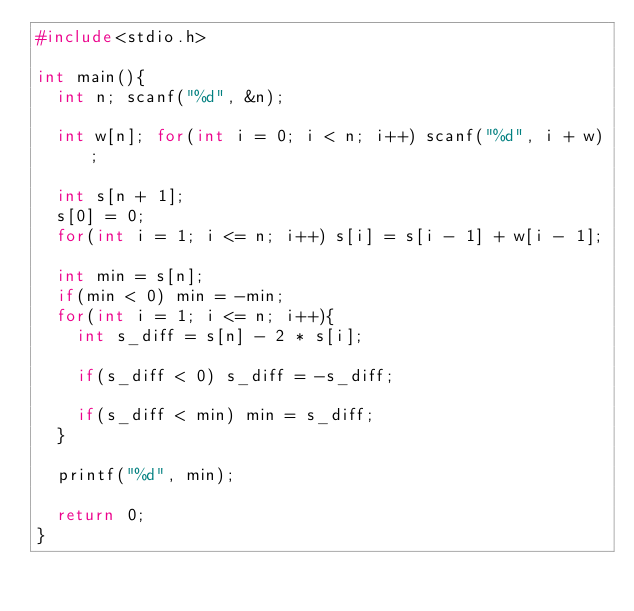<code> <loc_0><loc_0><loc_500><loc_500><_C_>#include<stdio.h>

int main(){
  int n; scanf("%d", &n);
  
  int w[n]; for(int i = 0; i < n; i++) scanf("%d", i + w);
  
  int s[n + 1];
  s[0] = 0;
  for(int i = 1; i <= n; i++) s[i] = s[i - 1] + w[i - 1];
  
  int min = s[n];
  if(min < 0) min = -min;
  for(int i = 1; i <= n; i++){
    int s_diff = s[n] - 2 * s[i];
    
    if(s_diff < 0) s_diff = -s_diff;
    
    if(s_diff < min) min = s_diff;
  }
  
  printf("%d", min);
  
  return 0;
}
</code> 